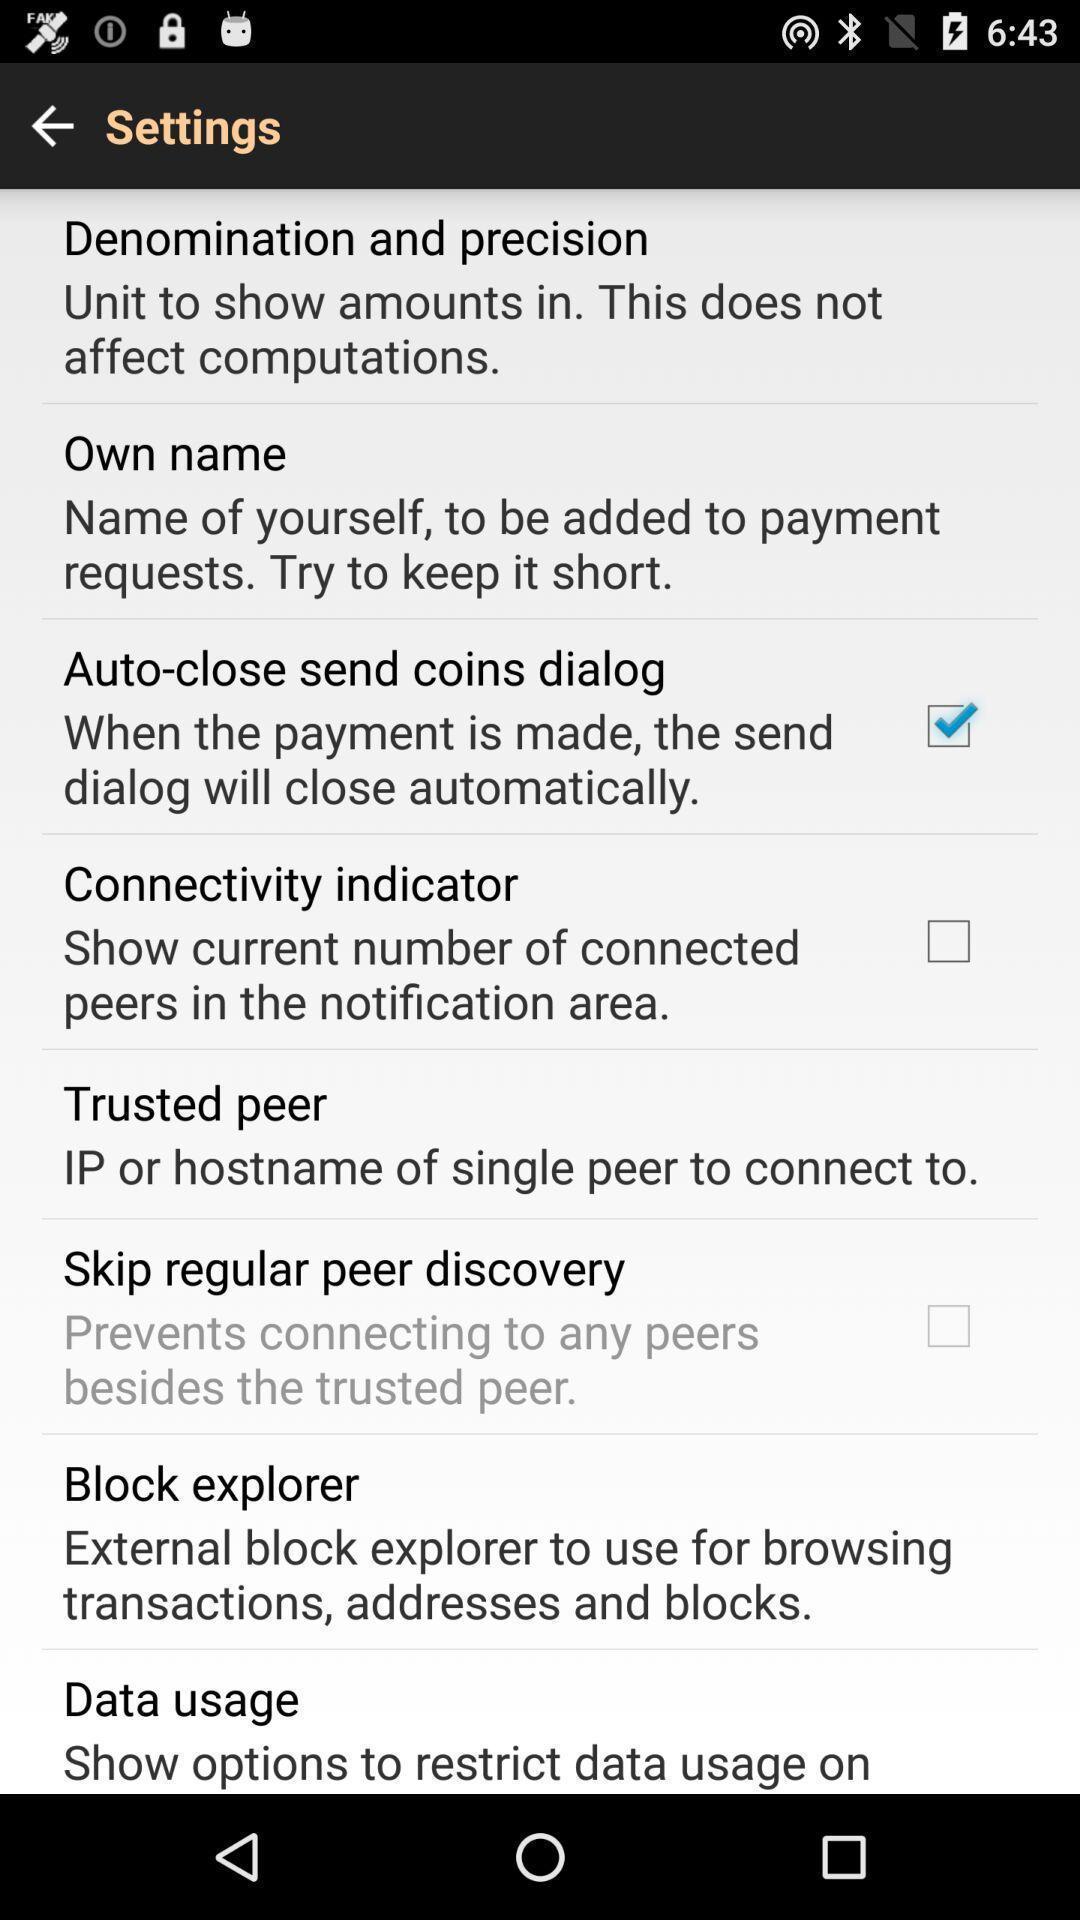Give me a narrative description of this picture. Screen displaying multiple setting options. 